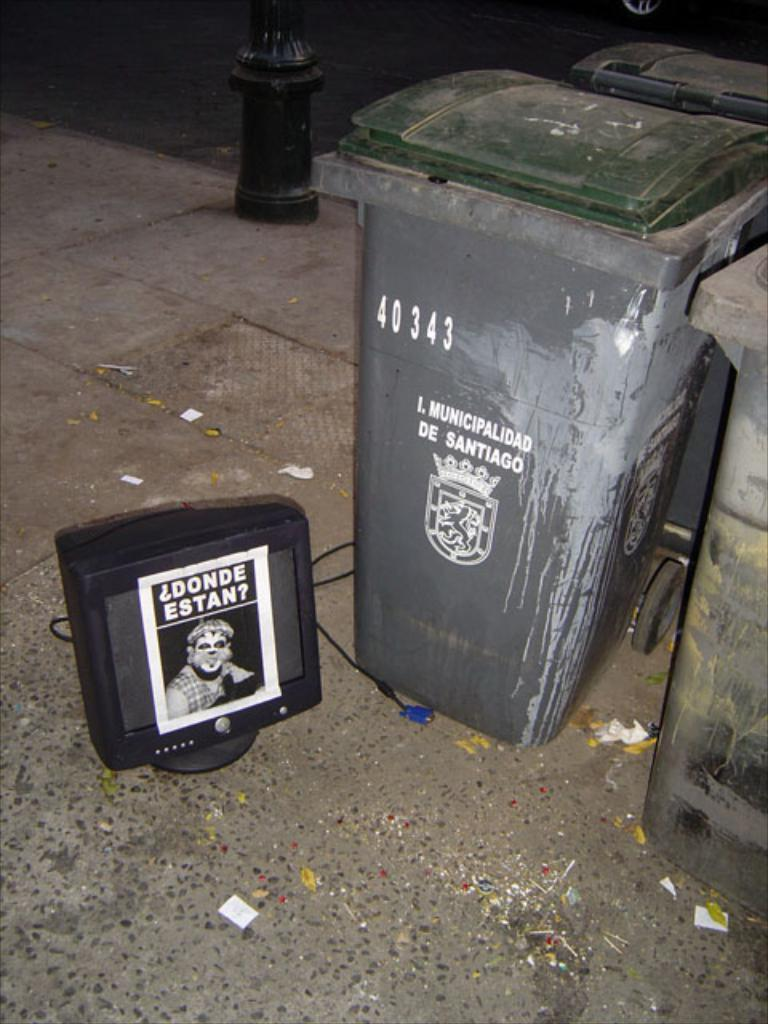What type of containers are present in the image? There are garbage bins in the image. What electronic device can be seen in the image? There is a television in the image. What is displayed on the television screen? A poster is visible on the television screen. What type of path is present in the image? There is a footpath in the image. What type of structure is present? There is a metal pole in the image. How many pears are on the metal pole in the image? There are no pears present in the image. What type of earthquake is depicted on the poster on the television screen? There is no earthquake depicted on the poster on the television screen; it is a poster, not an image of an earthquake. 